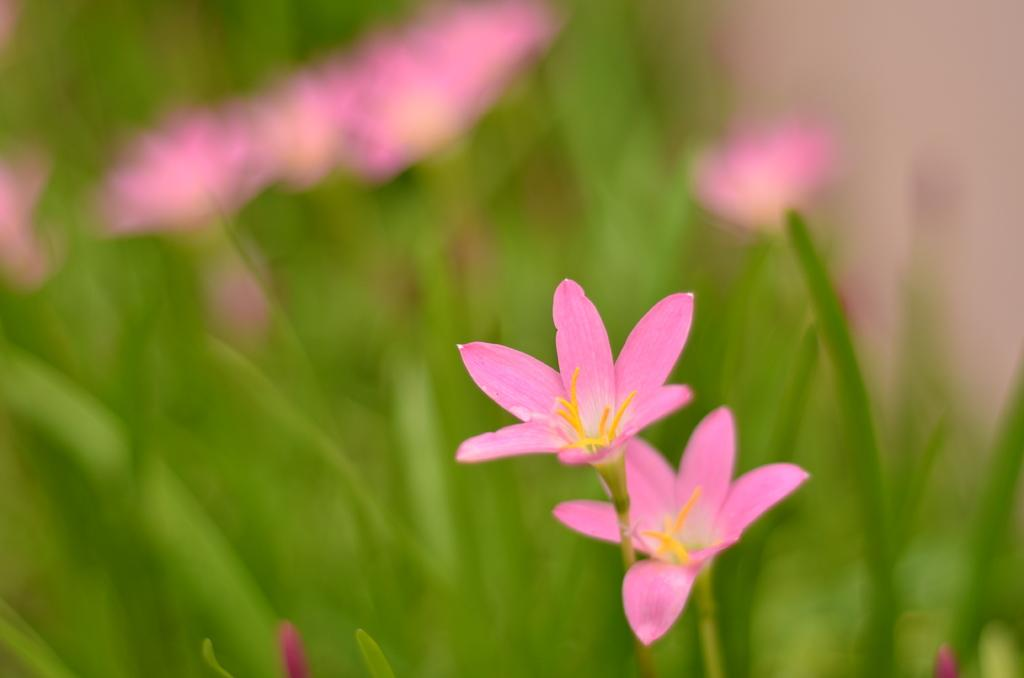What type of flowers can be seen in the image? There are beautiful pink flowers in the image. Are the flowers part of a plant or a separate object? The flowers are on plants. Who is flying the kite in the image? There is no kite present in the image. What does the uncle say about the birthday in the image? There is no mention of an uncle or a birthday in the image. 